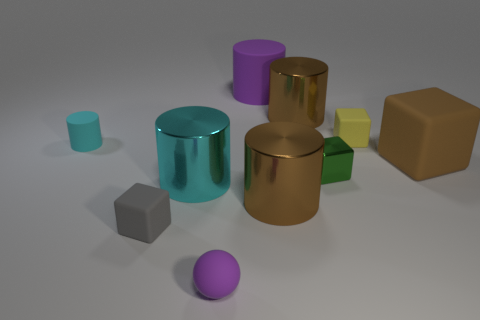Is the large matte cube the same color as the small cylinder?
Offer a very short reply. No. There is another cylinder that is the same color as the small matte cylinder; what is it made of?
Give a very brief answer. Metal. Is the number of small blocks on the right side of the big purple matte thing less than the number of metal blocks left of the metal block?
Provide a succinct answer. No. Does the ball have the same material as the small gray object?
Ensure brevity in your answer.  Yes. There is a matte thing that is behind the tiny gray block and to the left of the tiny purple rubber ball; what is its size?
Your answer should be compact. Small. Are there the same number of green rubber cylinders and big cyan cylinders?
Offer a very short reply. No. What is the shape of the gray rubber object that is the same size as the cyan rubber cylinder?
Offer a terse response. Cube. What is the material of the purple object behind the block that is on the left side of the shiny object to the left of the large rubber cylinder?
Offer a terse response. Rubber. There is a big brown object behind the small rubber cylinder; is its shape the same as the tiny rubber thing that is on the right side of the tiny rubber sphere?
Offer a terse response. No. What number of other things are made of the same material as the small cylinder?
Make the answer very short. 5. 